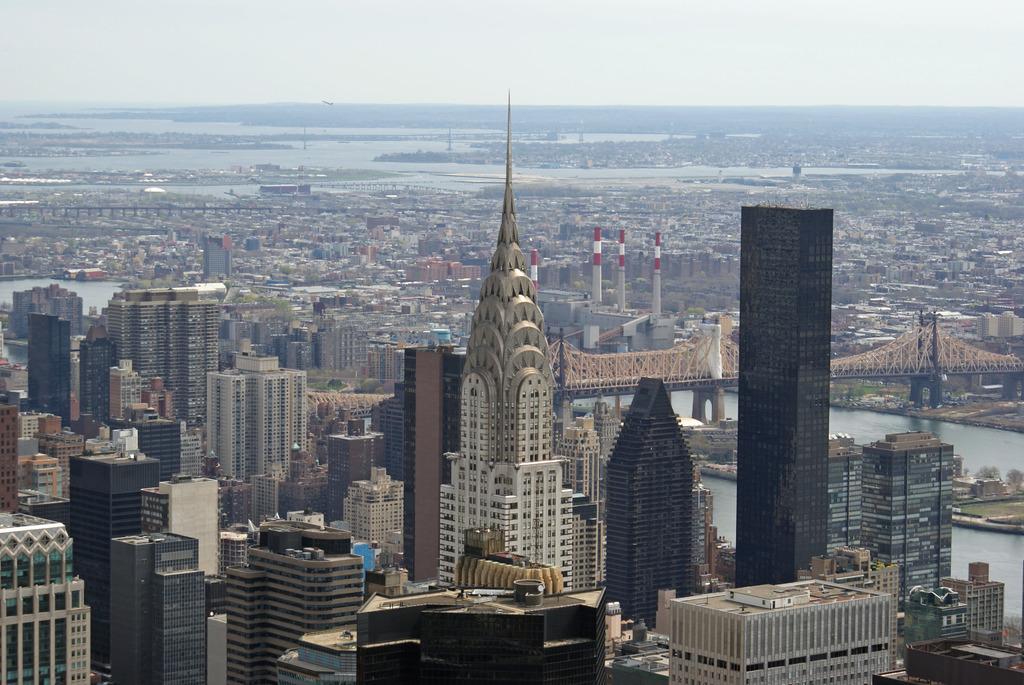Please provide a concise description of this image. There is a overview of a city. There is a bridge on the right side of this image and there is a sea at the bottom right side of this image. 